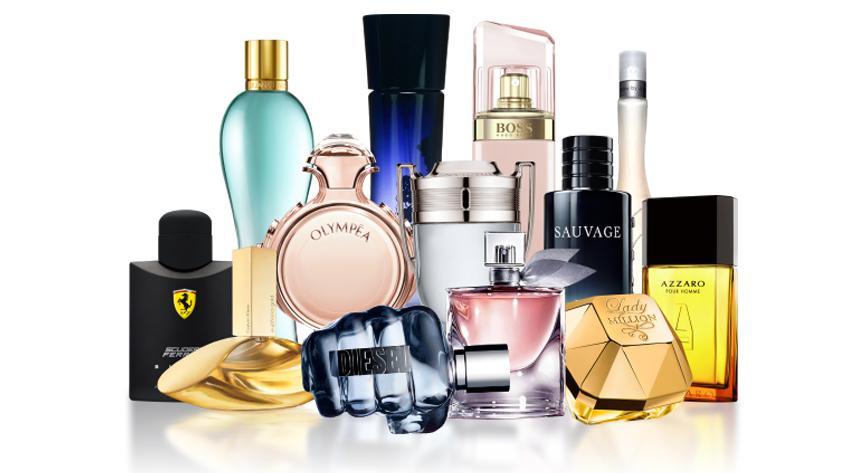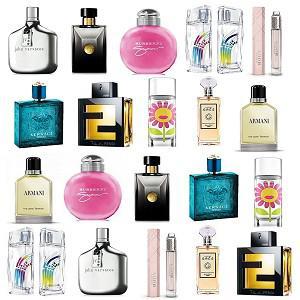The first image is the image on the left, the second image is the image on the right. Given the left and right images, does the statement "There is a single squared full chanel number 5 perfume bottle in at least one image." hold true? Answer yes or no. No. 